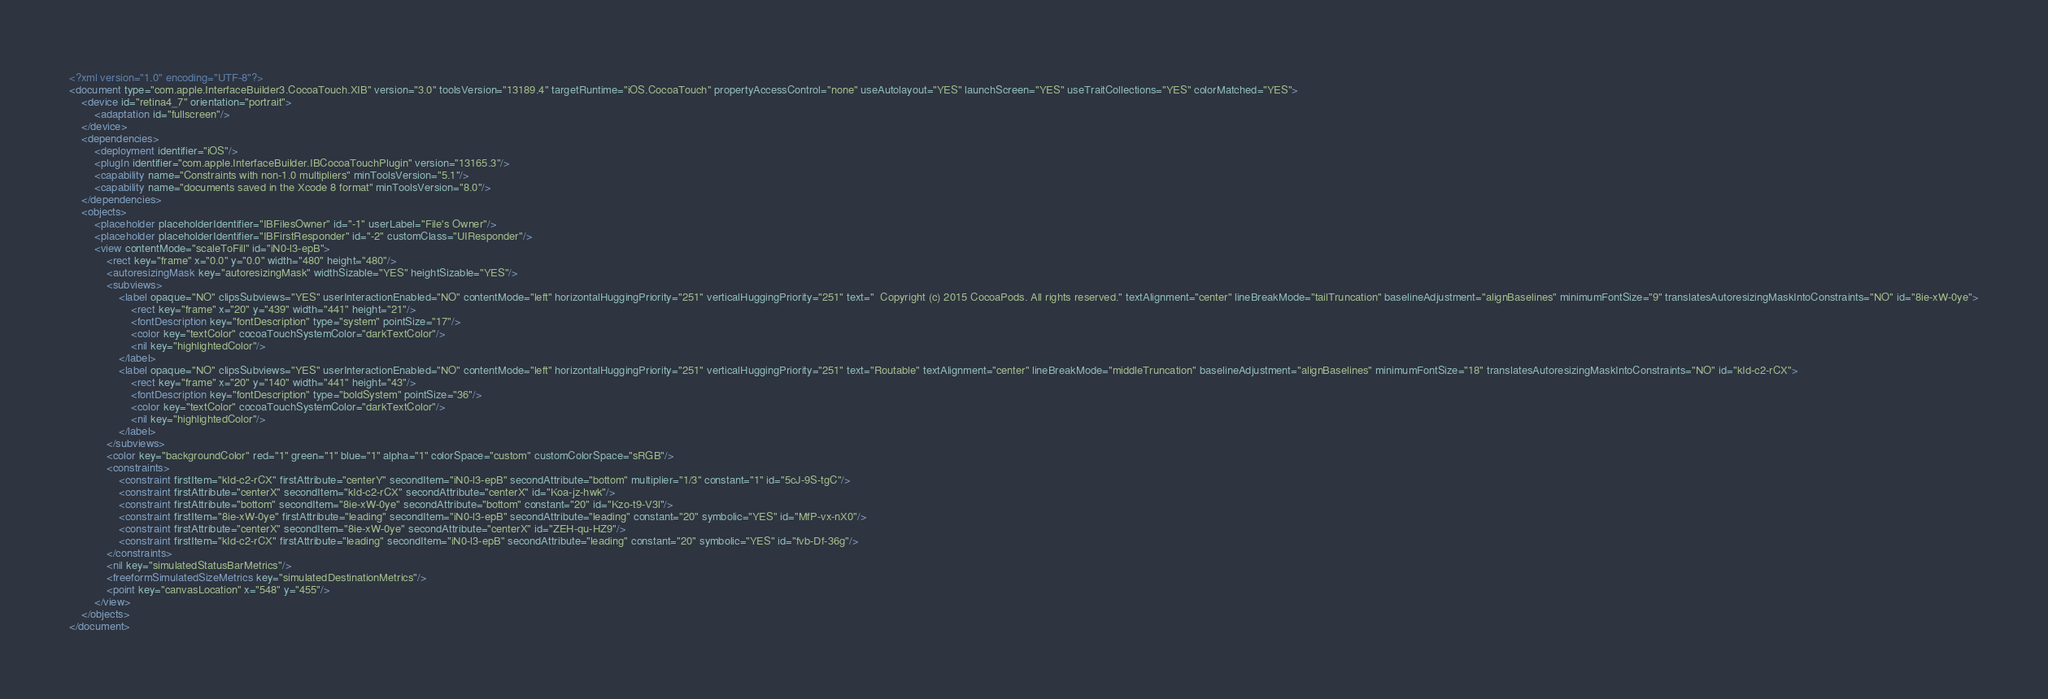<code> <loc_0><loc_0><loc_500><loc_500><_XML_><?xml version="1.0" encoding="UTF-8"?>
<document type="com.apple.InterfaceBuilder3.CocoaTouch.XIB" version="3.0" toolsVersion="13189.4" targetRuntime="iOS.CocoaTouch" propertyAccessControl="none" useAutolayout="YES" launchScreen="YES" useTraitCollections="YES" colorMatched="YES">
    <device id="retina4_7" orientation="portrait">
        <adaptation id="fullscreen"/>
    </device>
    <dependencies>
        <deployment identifier="iOS"/>
        <plugIn identifier="com.apple.InterfaceBuilder.IBCocoaTouchPlugin" version="13165.3"/>
        <capability name="Constraints with non-1.0 multipliers" minToolsVersion="5.1"/>
        <capability name="documents saved in the Xcode 8 format" minToolsVersion="8.0"/>
    </dependencies>
    <objects>
        <placeholder placeholderIdentifier="IBFilesOwner" id="-1" userLabel="File's Owner"/>
        <placeholder placeholderIdentifier="IBFirstResponder" id="-2" customClass="UIResponder"/>
        <view contentMode="scaleToFill" id="iN0-l3-epB">
            <rect key="frame" x="0.0" y="0.0" width="480" height="480"/>
            <autoresizingMask key="autoresizingMask" widthSizable="YES" heightSizable="YES"/>
            <subviews>
                <label opaque="NO" clipsSubviews="YES" userInteractionEnabled="NO" contentMode="left" horizontalHuggingPriority="251" verticalHuggingPriority="251" text="  Copyright (c) 2015 CocoaPods. All rights reserved." textAlignment="center" lineBreakMode="tailTruncation" baselineAdjustment="alignBaselines" minimumFontSize="9" translatesAutoresizingMaskIntoConstraints="NO" id="8ie-xW-0ye">
                    <rect key="frame" x="20" y="439" width="441" height="21"/>
                    <fontDescription key="fontDescription" type="system" pointSize="17"/>
                    <color key="textColor" cocoaTouchSystemColor="darkTextColor"/>
                    <nil key="highlightedColor"/>
                </label>
                <label opaque="NO" clipsSubviews="YES" userInteractionEnabled="NO" contentMode="left" horizontalHuggingPriority="251" verticalHuggingPriority="251" text="Routable" textAlignment="center" lineBreakMode="middleTruncation" baselineAdjustment="alignBaselines" minimumFontSize="18" translatesAutoresizingMaskIntoConstraints="NO" id="kId-c2-rCX">
                    <rect key="frame" x="20" y="140" width="441" height="43"/>
                    <fontDescription key="fontDescription" type="boldSystem" pointSize="36"/>
                    <color key="textColor" cocoaTouchSystemColor="darkTextColor"/>
                    <nil key="highlightedColor"/>
                </label>
            </subviews>
            <color key="backgroundColor" red="1" green="1" blue="1" alpha="1" colorSpace="custom" customColorSpace="sRGB"/>
            <constraints>
                <constraint firstItem="kId-c2-rCX" firstAttribute="centerY" secondItem="iN0-l3-epB" secondAttribute="bottom" multiplier="1/3" constant="1" id="5cJ-9S-tgC"/>
                <constraint firstAttribute="centerX" secondItem="kId-c2-rCX" secondAttribute="centerX" id="Koa-jz-hwk"/>
                <constraint firstAttribute="bottom" secondItem="8ie-xW-0ye" secondAttribute="bottom" constant="20" id="Kzo-t9-V3l"/>
                <constraint firstItem="8ie-xW-0ye" firstAttribute="leading" secondItem="iN0-l3-epB" secondAttribute="leading" constant="20" symbolic="YES" id="MfP-vx-nX0"/>
                <constraint firstAttribute="centerX" secondItem="8ie-xW-0ye" secondAttribute="centerX" id="ZEH-qu-HZ9"/>
                <constraint firstItem="kId-c2-rCX" firstAttribute="leading" secondItem="iN0-l3-epB" secondAttribute="leading" constant="20" symbolic="YES" id="fvb-Df-36g"/>
            </constraints>
            <nil key="simulatedStatusBarMetrics"/>
            <freeformSimulatedSizeMetrics key="simulatedDestinationMetrics"/>
            <point key="canvasLocation" x="548" y="455"/>
        </view>
    </objects>
</document>
</code> 